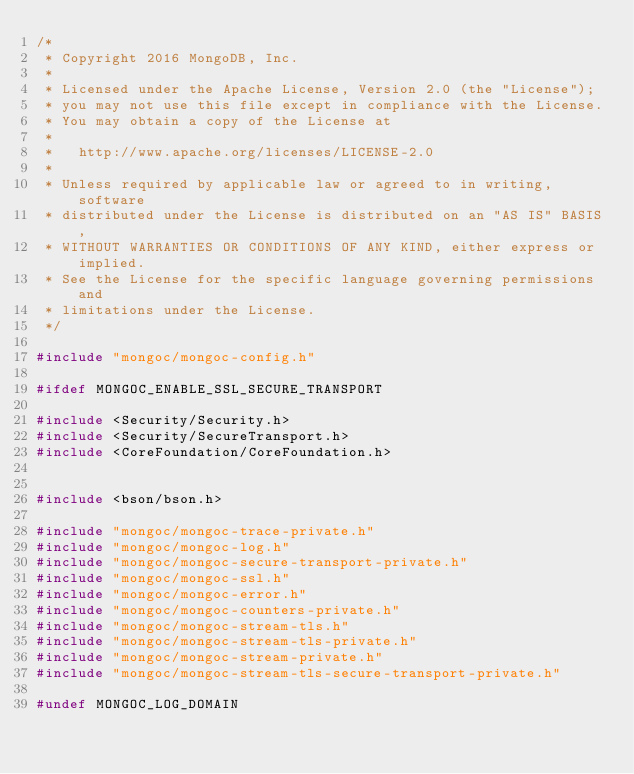<code> <loc_0><loc_0><loc_500><loc_500><_C_>/*
 * Copyright 2016 MongoDB, Inc.
 *
 * Licensed under the Apache License, Version 2.0 (the "License");
 * you may not use this file except in compliance with the License.
 * You may obtain a copy of the License at
 *
 *   http://www.apache.org/licenses/LICENSE-2.0
 *
 * Unless required by applicable law or agreed to in writing, software
 * distributed under the License is distributed on an "AS IS" BASIS,
 * WITHOUT WARRANTIES OR CONDITIONS OF ANY KIND, either express or implied.
 * See the License for the specific language governing permissions and
 * limitations under the License.
 */

#include "mongoc/mongoc-config.h"

#ifdef MONGOC_ENABLE_SSL_SECURE_TRANSPORT

#include <Security/Security.h>
#include <Security/SecureTransport.h>
#include <CoreFoundation/CoreFoundation.h>


#include <bson/bson.h>

#include "mongoc/mongoc-trace-private.h"
#include "mongoc/mongoc-log.h"
#include "mongoc/mongoc-secure-transport-private.h"
#include "mongoc/mongoc-ssl.h"
#include "mongoc/mongoc-error.h"
#include "mongoc/mongoc-counters-private.h"
#include "mongoc/mongoc-stream-tls.h"
#include "mongoc/mongoc-stream-tls-private.h"
#include "mongoc/mongoc-stream-private.h"
#include "mongoc/mongoc-stream-tls-secure-transport-private.h"

#undef MONGOC_LOG_DOMAIN</code> 